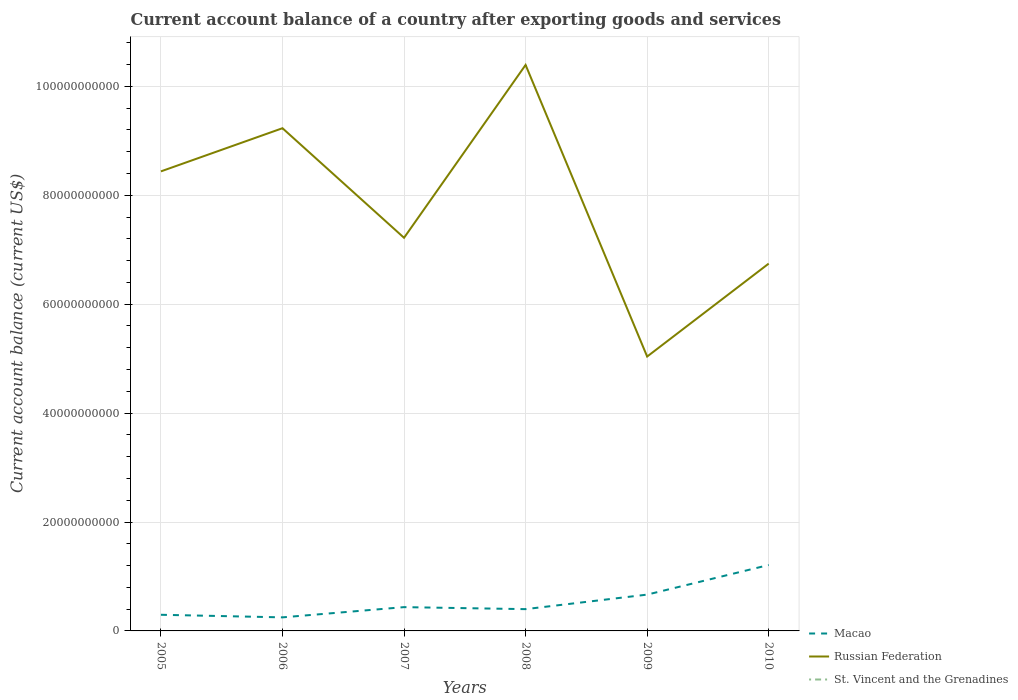Does the line corresponding to St. Vincent and the Grenadines intersect with the line corresponding to Russian Federation?
Your response must be concise. No. Across all years, what is the maximum account balance in Russian Federation?
Give a very brief answer. 5.04e+1. What is the total account balance in Macao in the graph?
Provide a short and direct response. -7.74e+09. What is the difference between the highest and the second highest account balance in Russian Federation?
Your response must be concise. 5.36e+1. How many years are there in the graph?
Provide a short and direct response. 6. Are the values on the major ticks of Y-axis written in scientific E-notation?
Your response must be concise. No. Does the graph contain any zero values?
Make the answer very short. Yes. Does the graph contain grids?
Give a very brief answer. Yes. How many legend labels are there?
Offer a very short reply. 3. How are the legend labels stacked?
Give a very brief answer. Vertical. What is the title of the graph?
Give a very brief answer. Current account balance of a country after exporting goods and services. Does "Kiribati" appear as one of the legend labels in the graph?
Your answer should be very brief. No. What is the label or title of the X-axis?
Provide a short and direct response. Years. What is the label or title of the Y-axis?
Your response must be concise. Current account balance (current US$). What is the Current account balance (current US$) of Macao in 2005?
Give a very brief answer. 2.96e+09. What is the Current account balance (current US$) of Russian Federation in 2005?
Offer a very short reply. 8.44e+1. What is the Current account balance (current US$) in St. Vincent and the Grenadines in 2005?
Offer a very short reply. 0. What is the Current account balance (current US$) of Macao in 2006?
Give a very brief answer. 2.49e+09. What is the Current account balance (current US$) of Russian Federation in 2006?
Give a very brief answer. 9.23e+1. What is the Current account balance (current US$) in Macao in 2007?
Give a very brief answer. 4.37e+09. What is the Current account balance (current US$) of Russian Federation in 2007?
Offer a very short reply. 7.22e+1. What is the Current account balance (current US$) of Macao in 2008?
Make the answer very short. 4.00e+09. What is the Current account balance (current US$) in Russian Federation in 2008?
Provide a short and direct response. 1.04e+11. What is the Current account balance (current US$) of Macao in 2009?
Ensure brevity in your answer.  6.67e+09. What is the Current account balance (current US$) of Russian Federation in 2009?
Your answer should be compact. 5.04e+1. What is the Current account balance (current US$) of Macao in 2010?
Ensure brevity in your answer.  1.21e+1. What is the Current account balance (current US$) in Russian Federation in 2010?
Your answer should be compact. 6.75e+1. What is the Current account balance (current US$) in St. Vincent and the Grenadines in 2010?
Your answer should be very brief. 0. Across all years, what is the maximum Current account balance (current US$) of Macao?
Your answer should be compact. 1.21e+1. Across all years, what is the maximum Current account balance (current US$) in Russian Federation?
Ensure brevity in your answer.  1.04e+11. Across all years, what is the minimum Current account balance (current US$) in Macao?
Keep it short and to the point. 2.49e+09. Across all years, what is the minimum Current account balance (current US$) of Russian Federation?
Ensure brevity in your answer.  5.04e+1. What is the total Current account balance (current US$) in Macao in the graph?
Make the answer very short. 3.26e+1. What is the total Current account balance (current US$) in Russian Federation in the graph?
Keep it short and to the point. 4.71e+11. What is the difference between the Current account balance (current US$) of Macao in 2005 and that in 2006?
Give a very brief answer. 4.75e+08. What is the difference between the Current account balance (current US$) of Russian Federation in 2005 and that in 2006?
Give a very brief answer. -7.93e+09. What is the difference between the Current account balance (current US$) of Macao in 2005 and that in 2007?
Make the answer very short. -1.40e+09. What is the difference between the Current account balance (current US$) in Russian Federation in 2005 and that in 2007?
Make the answer very short. 1.22e+1. What is the difference between the Current account balance (current US$) of Macao in 2005 and that in 2008?
Your answer should be compact. -1.03e+09. What is the difference between the Current account balance (current US$) of Russian Federation in 2005 and that in 2008?
Provide a succinct answer. -1.95e+1. What is the difference between the Current account balance (current US$) in Macao in 2005 and that in 2009?
Your answer should be very brief. -3.70e+09. What is the difference between the Current account balance (current US$) in Russian Federation in 2005 and that in 2009?
Ensure brevity in your answer.  3.40e+1. What is the difference between the Current account balance (current US$) in Macao in 2005 and that in 2010?
Offer a terse response. -9.14e+09. What is the difference between the Current account balance (current US$) in Russian Federation in 2005 and that in 2010?
Offer a terse response. 1.69e+1. What is the difference between the Current account balance (current US$) of Macao in 2006 and that in 2007?
Your response must be concise. -1.88e+09. What is the difference between the Current account balance (current US$) in Russian Federation in 2006 and that in 2007?
Your response must be concise. 2.01e+1. What is the difference between the Current account balance (current US$) of Macao in 2006 and that in 2008?
Your answer should be very brief. -1.51e+09. What is the difference between the Current account balance (current US$) of Russian Federation in 2006 and that in 2008?
Provide a succinct answer. -1.16e+1. What is the difference between the Current account balance (current US$) of Macao in 2006 and that in 2009?
Make the answer very short. -4.18e+09. What is the difference between the Current account balance (current US$) of Russian Federation in 2006 and that in 2009?
Offer a very short reply. 4.19e+1. What is the difference between the Current account balance (current US$) in Macao in 2006 and that in 2010?
Your response must be concise. -9.61e+09. What is the difference between the Current account balance (current US$) in Russian Federation in 2006 and that in 2010?
Give a very brief answer. 2.49e+1. What is the difference between the Current account balance (current US$) of Macao in 2007 and that in 2008?
Your answer should be very brief. 3.69e+08. What is the difference between the Current account balance (current US$) of Russian Federation in 2007 and that in 2008?
Offer a terse response. -3.17e+1. What is the difference between the Current account balance (current US$) in Macao in 2007 and that in 2009?
Keep it short and to the point. -2.30e+09. What is the difference between the Current account balance (current US$) of Russian Federation in 2007 and that in 2009?
Provide a short and direct response. 2.18e+1. What is the difference between the Current account balance (current US$) of Macao in 2007 and that in 2010?
Provide a succinct answer. -7.74e+09. What is the difference between the Current account balance (current US$) in Russian Federation in 2007 and that in 2010?
Offer a terse response. 4.74e+09. What is the difference between the Current account balance (current US$) of Macao in 2008 and that in 2009?
Provide a succinct answer. -2.67e+09. What is the difference between the Current account balance (current US$) of Russian Federation in 2008 and that in 2009?
Keep it short and to the point. 5.36e+1. What is the difference between the Current account balance (current US$) of Macao in 2008 and that in 2010?
Keep it short and to the point. -8.10e+09. What is the difference between the Current account balance (current US$) of Russian Federation in 2008 and that in 2010?
Offer a very short reply. 3.65e+1. What is the difference between the Current account balance (current US$) in Macao in 2009 and that in 2010?
Make the answer very short. -5.44e+09. What is the difference between the Current account balance (current US$) of Russian Federation in 2009 and that in 2010?
Offer a terse response. -1.71e+1. What is the difference between the Current account balance (current US$) of Macao in 2005 and the Current account balance (current US$) of Russian Federation in 2006?
Your answer should be compact. -8.94e+1. What is the difference between the Current account balance (current US$) of Macao in 2005 and the Current account balance (current US$) of Russian Federation in 2007?
Offer a very short reply. -6.92e+1. What is the difference between the Current account balance (current US$) of Macao in 2005 and the Current account balance (current US$) of Russian Federation in 2008?
Your response must be concise. -1.01e+11. What is the difference between the Current account balance (current US$) of Macao in 2005 and the Current account balance (current US$) of Russian Federation in 2009?
Give a very brief answer. -4.74e+1. What is the difference between the Current account balance (current US$) of Macao in 2005 and the Current account balance (current US$) of Russian Federation in 2010?
Ensure brevity in your answer.  -6.45e+1. What is the difference between the Current account balance (current US$) in Macao in 2006 and the Current account balance (current US$) in Russian Federation in 2007?
Make the answer very short. -6.97e+1. What is the difference between the Current account balance (current US$) in Macao in 2006 and the Current account balance (current US$) in Russian Federation in 2008?
Your answer should be compact. -1.01e+11. What is the difference between the Current account balance (current US$) in Macao in 2006 and the Current account balance (current US$) in Russian Federation in 2009?
Keep it short and to the point. -4.79e+1. What is the difference between the Current account balance (current US$) in Macao in 2006 and the Current account balance (current US$) in Russian Federation in 2010?
Offer a very short reply. -6.50e+1. What is the difference between the Current account balance (current US$) of Macao in 2007 and the Current account balance (current US$) of Russian Federation in 2008?
Ensure brevity in your answer.  -9.96e+1. What is the difference between the Current account balance (current US$) of Macao in 2007 and the Current account balance (current US$) of Russian Federation in 2009?
Provide a short and direct response. -4.60e+1. What is the difference between the Current account balance (current US$) in Macao in 2007 and the Current account balance (current US$) in Russian Federation in 2010?
Your answer should be compact. -6.31e+1. What is the difference between the Current account balance (current US$) of Macao in 2008 and the Current account balance (current US$) of Russian Federation in 2009?
Offer a very short reply. -4.64e+1. What is the difference between the Current account balance (current US$) in Macao in 2008 and the Current account balance (current US$) in Russian Federation in 2010?
Provide a short and direct response. -6.35e+1. What is the difference between the Current account balance (current US$) in Macao in 2009 and the Current account balance (current US$) in Russian Federation in 2010?
Make the answer very short. -6.08e+1. What is the average Current account balance (current US$) of Macao per year?
Offer a very short reply. 5.43e+09. What is the average Current account balance (current US$) of Russian Federation per year?
Your response must be concise. 7.84e+1. What is the average Current account balance (current US$) in St. Vincent and the Grenadines per year?
Keep it short and to the point. 0. In the year 2005, what is the difference between the Current account balance (current US$) in Macao and Current account balance (current US$) in Russian Federation?
Make the answer very short. -8.14e+1. In the year 2006, what is the difference between the Current account balance (current US$) of Macao and Current account balance (current US$) of Russian Federation?
Provide a short and direct response. -8.98e+1. In the year 2007, what is the difference between the Current account balance (current US$) of Macao and Current account balance (current US$) of Russian Federation?
Make the answer very short. -6.78e+1. In the year 2008, what is the difference between the Current account balance (current US$) in Macao and Current account balance (current US$) in Russian Federation?
Give a very brief answer. -9.99e+1. In the year 2009, what is the difference between the Current account balance (current US$) of Macao and Current account balance (current US$) of Russian Federation?
Your response must be concise. -4.37e+1. In the year 2010, what is the difference between the Current account balance (current US$) of Macao and Current account balance (current US$) of Russian Federation?
Your answer should be compact. -5.53e+1. What is the ratio of the Current account balance (current US$) in Macao in 2005 to that in 2006?
Your response must be concise. 1.19. What is the ratio of the Current account balance (current US$) in Russian Federation in 2005 to that in 2006?
Your answer should be very brief. 0.91. What is the ratio of the Current account balance (current US$) in Macao in 2005 to that in 2007?
Your answer should be compact. 0.68. What is the ratio of the Current account balance (current US$) in Russian Federation in 2005 to that in 2007?
Offer a very short reply. 1.17. What is the ratio of the Current account balance (current US$) of Macao in 2005 to that in 2008?
Give a very brief answer. 0.74. What is the ratio of the Current account balance (current US$) in Russian Federation in 2005 to that in 2008?
Provide a succinct answer. 0.81. What is the ratio of the Current account balance (current US$) of Macao in 2005 to that in 2009?
Keep it short and to the point. 0.44. What is the ratio of the Current account balance (current US$) in Russian Federation in 2005 to that in 2009?
Provide a short and direct response. 1.67. What is the ratio of the Current account balance (current US$) in Macao in 2005 to that in 2010?
Offer a very short reply. 0.24. What is the ratio of the Current account balance (current US$) of Russian Federation in 2005 to that in 2010?
Make the answer very short. 1.25. What is the ratio of the Current account balance (current US$) of Macao in 2006 to that in 2007?
Offer a very short reply. 0.57. What is the ratio of the Current account balance (current US$) in Russian Federation in 2006 to that in 2007?
Offer a terse response. 1.28. What is the ratio of the Current account balance (current US$) of Macao in 2006 to that in 2008?
Your answer should be very brief. 0.62. What is the ratio of the Current account balance (current US$) in Russian Federation in 2006 to that in 2008?
Give a very brief answer. 0.89. What is the ratio of the Current account balance (current US$) in Macao in 2006 to that in 2009?
Your answer should be very brief. 0.37. What is the ratio of the Current account balance (current US$) in Russian Federation in 2006 to that in 2009?
Give a very brief answer. 1.83. What is the ratio of the Current account balance (current US$) of Macao in 2006 to that in 2010?
Offer a very short reply. 0.21. What is the ratio of the Current account balance (current US$) of Russian Federation in 2006 to that in 2010?
Provide a succinct answer. 1.37. What is the ratio of the Current account balance (current US$) of Macao in 2007 to that in 2008?
Keep it short and to the point. 1.09. What is the ratio of the Current account balance (current US$) of Russian Federation in 2007 to that in 2008?
Your response must be concise. 0.69. What is the ratio of the Current account balance (current US$) in Macao in 2007 to that in 2009?
Your answer should be very brief. 0.66. What is the ratio of the Current account balance (current US$) in Russian Federation in 2007 to that in 2009?
Offer a very short reply. 1.43. What is the ratio of the Current account balance (current US$) in Macao in 2007 to that in 2010?
Offer a very short reply. 0.36. What is the ratio of the Current account balance (current US$) of Russian Federation in 2007 to that in 2010?
Provide a short and direct response. 1.07. What is the ratio of the Current account balance (current US$) of Macao in 2008 to that in 2009?
Make the answer very short. 0.6. What is the ratio of the Current account balance (current US$) in Russian Federation in 2008 to that in 2009?
Your response must be concise. 2.06. What is the ratio of the Current account balance (current US$) of Macao in 2008 to that in 2010?
Keep it short and to the point. 0.33. What is the ratio of the Current account balance (current US$) in Russian Federation in 2008 to that in 2010?
Your response must be concise. 1.54. What is the ratio of the Current account balance (current US$) in Macao in 2009 to that in 2010?
Keep it short and to the point. 0.55. What is the ratio of the Current account balance (current US$) of Russian Federation in 2009 to that in 2010?
Your answer should be compact. 0.75. What is the difference between the highest and the second highest Current account balance (current US$) in Macao?
Ensure brevity in your answer.  5.44e+09. What is the difference between the highest and the second highest Current account balance (current US$) of Russian Federation?
Make the answer very short. 1.16e+1. What is the difference between the highest and the lowest Current account balance (current US$) in Macao?
Your answer should be compact. 9.61e+09. What is the difference between the highest and the lowest Current account balance (current US$) in Russian Federation?
Keep it short and to the point. 5.36e+1. 